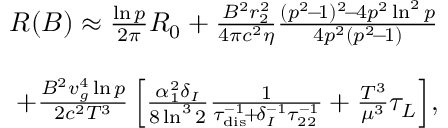<formula> <loc_0><loc_0><loc_500><loc_500>\begin{array} { r l r } & { R ( B ) \approx \frac { \ln p } { 2 \pi } R _ { 0 } + \frac { B ^ { 2 } r _ { 2 } ^ { 2 } } { 4 \pi c ^ { 2 } \eta } \frac { ( p ^ { 2 } \, - \, 1 ) ^ { 2 } \, - \, 4 p ^ { 2 } \ln ^ { 2 } p } { 4 p ^ { 2 } ( p ^ { 2 } \, - \, 1 ) } } \\ & \\ & { \quad + \frac { B ^ { 2 } v _ { g } ^ { 4 } \ln p } { 2 c ^ { 2 } T ^ { 3 } } \left [ \frac { \alpha _ { 1 } ^ { 2 } \delta _ { I } } { 8 \ln ^ { 3 } 2 } \frac { 1 } { \tau _ { d i s } ^ { - 1 } \, + \, \delta _ { I } ^ { - 1 } \tau _ { 2 2 } ^ { - 1 } } + \frac { T ^ { 3 } } { \mu ^ { 3 } } \tau _ { L } \right ] \, , } \end{array}</formula> 